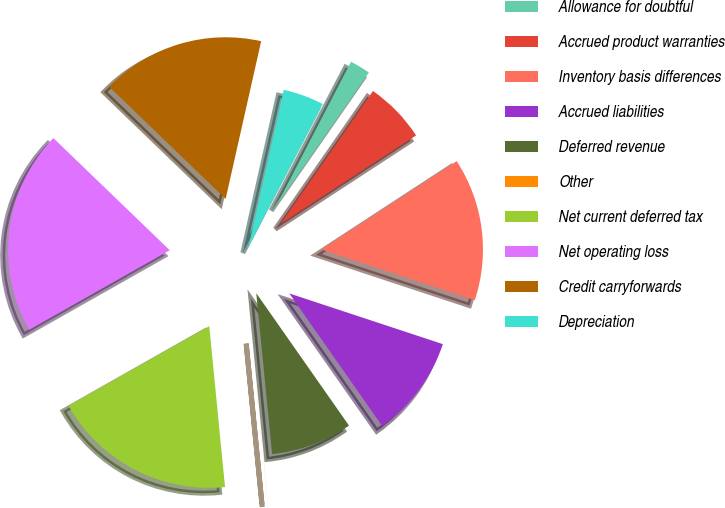Convert chart to OTSL. <chart><loc_0><loc_0><loc_500><loc_500><pie_chart><fcel>Allowance for doubtful<fcel>Accrued product warranties<fcel>Inventory basis differences<fcel>Accrued liabilities<fcel>Deferred revenue<fcel>Other<fcel>Net current deferred tax<fcel>Net operating loss<fcel>Credit carryforwards<fcel>Depreciation<nl><fcel>2.05%<fcel>6.13%<fcel>14.28%<fcel>10.2%<fcel>8.16%<fcel>0.01%<fcel>18.36%<fcel>20.4%<fcel>16.32%<fcel>4.09%<nl></chart> 